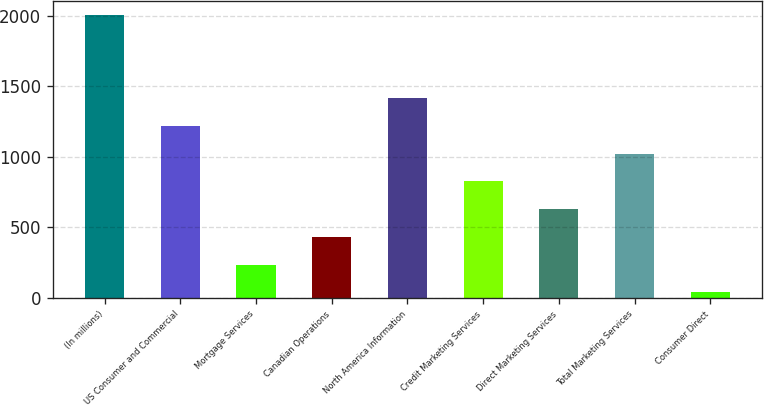Convert chart to OTSL. <chart><loc_0><loc_0><loc_500><loc_500><bar_chart><fcel>(In millions)<fcel>US Consumer and Commercial<fcel>Mortgage Services<fcel>Canadian Operations<fcel>North America Information<fcel>Credit Marketing Services<fcel>Direct Marketing Services<fcel>Total Marketing Services<fcel>Consumer Direct<nl><fcel>2002<fcel>1216.96<fcel>235.66<fcel>431.92<fcel>1413.22<fcel>824.44<fcel>628.18<fcel>1020.7<fcel>39.4<nl></chart> 